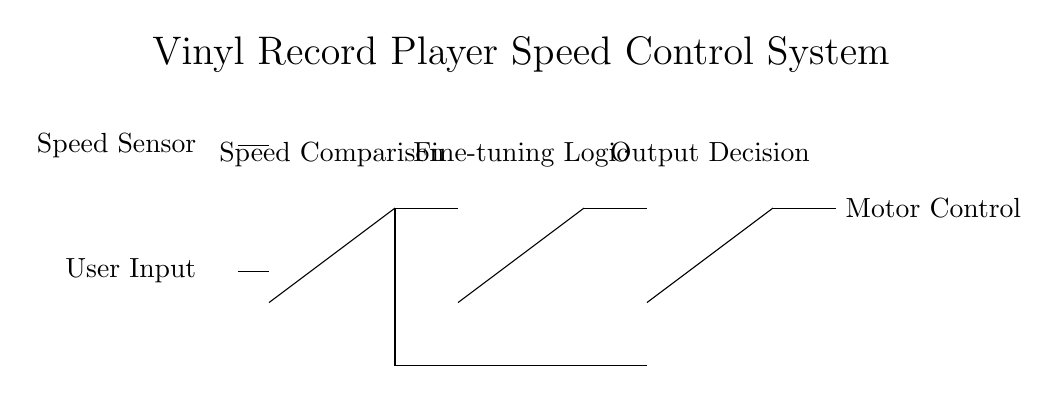What is the primary function of the XOR gate in this circuit? The XOR gate compares the outputs from the speed sensor and user input. It allows a signal to pass only if one of the inputs is high and the other is low, which helps determine if the current speed matches the desired speed.
Answer: Speed comparison How many logic gates are present in this circuit? There are four logic gates: one XOR, one AND, one NOT, and one OR gate. Counting each gate gives a total of four different types.
Answer: Four What kind of signal does the motor control output? As a result of the output from the OR gate, the motor control receives a signal that can either turn on the motor or keep it off based on the logic applied in the circuit. This is a binary output, which results from the logical decisions made by the gates.
Answer: Binary Which gate's output indicates a fine-tuning adjustment needed in speed? The output from the AND gate indicates that fine-tuning is necessary. If both inputs to the AND gate are high, it signifies that adjustments may be required because the desired speed is not being met accurately, as decided by the earlier XOR logic.
Answer: AND gate Which components provide the input to the XOR gate? The XOR gate takes input from the speed sensor and user input. These inputs are critical for determining if adjustments need to be made to the playback speed based on user preferences compared to the current speed.
Answer: Speed sensor and user input 